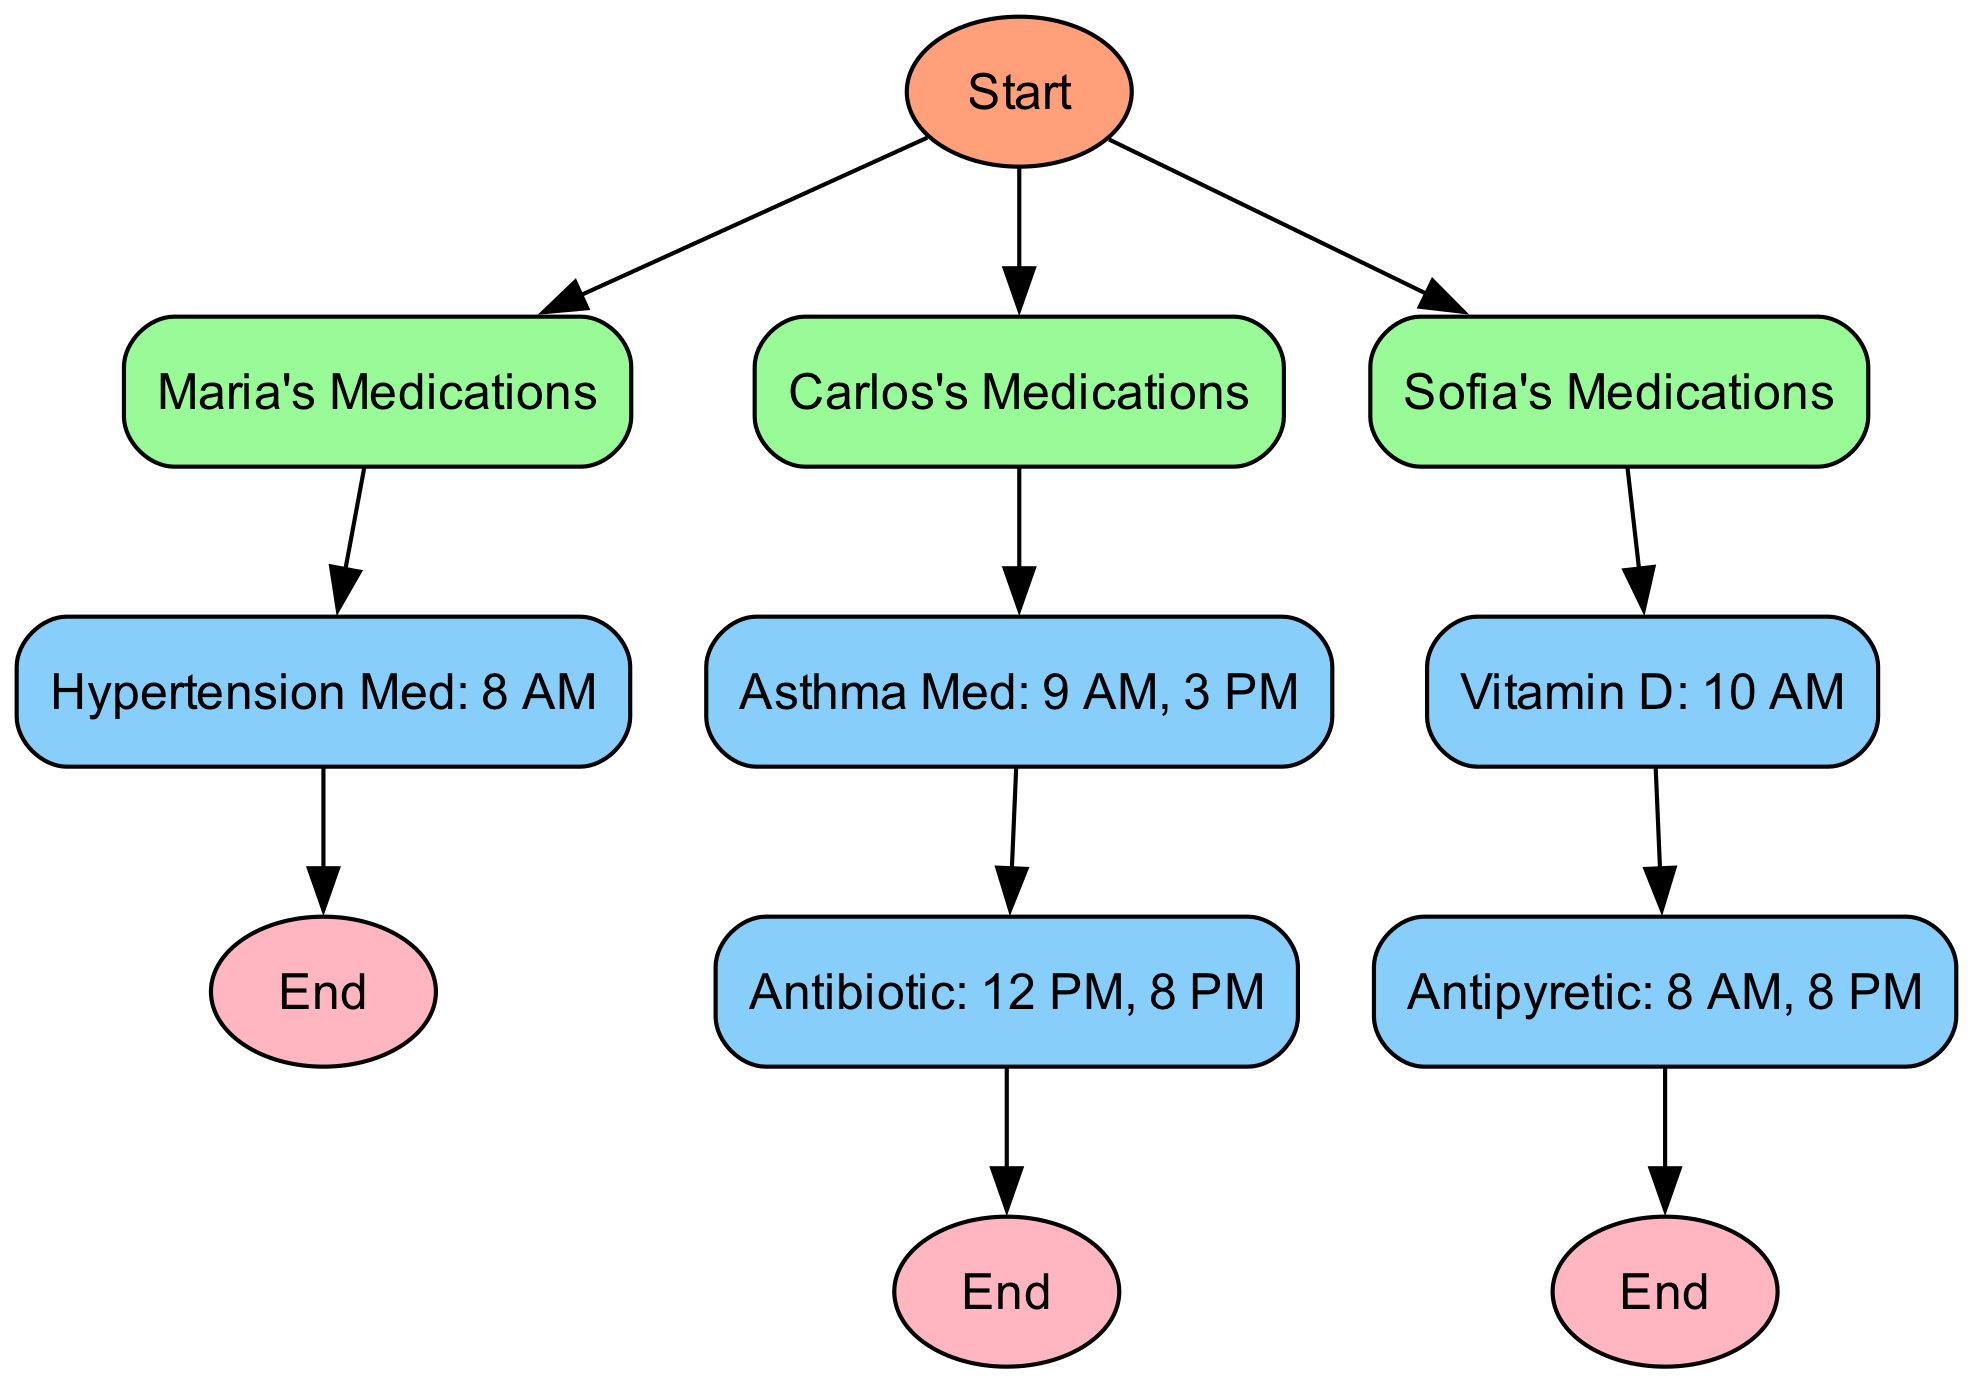What is the first medication listed for Maria? The flowchart indicates that the first medication under Maria's Medications is "Hypertension Med" which is scheduled for "8 AM."
Answer: Hypertension Med How many medications does Carlos have? The diagram lists two medications for Carlos: "Asthma Med" and "Antibiotic." Therefore, the total is two.
Answer: 2 What time should Sofia take her vitamin? According to the flowchart, Sofia should take her "Vitamin D" at "10 AM."
Answer: 10 AM Which medication for Carlos has multiple times listed? The medication "Antibiotic" for Carlos has multiple administration times: "12 PM" and "8 PM."
Answer: Antibiotic What is the last node for Sofia's medications? The last medication listed in the flowchart for Sofia is "Antipyretic," followed by an end node. Thus, "Antipyretic" is the final step for her medications.
Answer: Antipyretic How many total end nodes are there in the diagram? The diagram contains three end nodes, one for each family member’s medication flow (Maria, Carlos, Sofia).
Answer: 3 What are the critical timings for Carlos's medication? The critical timings for Carlos's medications are "9 AM" for Asthma Med and "12 PM, 8 PM" for Antibiotic, indicating multiple timings.
Answer: 9 AM, 12 PM, 8 PM Which family member takes medication at 8 PM? The flowchart shows both Maria (Antipyretic) and Carlos (Antibiotic) taking medication at 8 PM, indicating both family members are involved.
Answer: Maria and Carlos What color represents the medications in the diagram? The medications are represented in the flowchart with a light blue color, specifically denoted by the code color "#87CEFA."
Answer: Light blue 